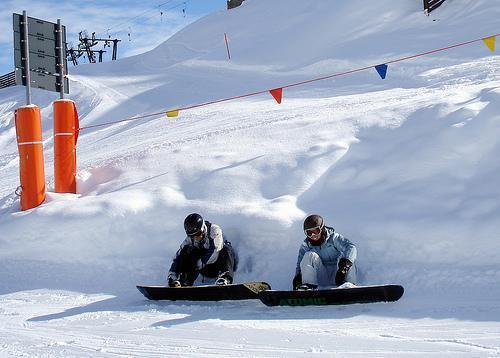How many yellow flags are there?
Give a very brief answer. 2. 